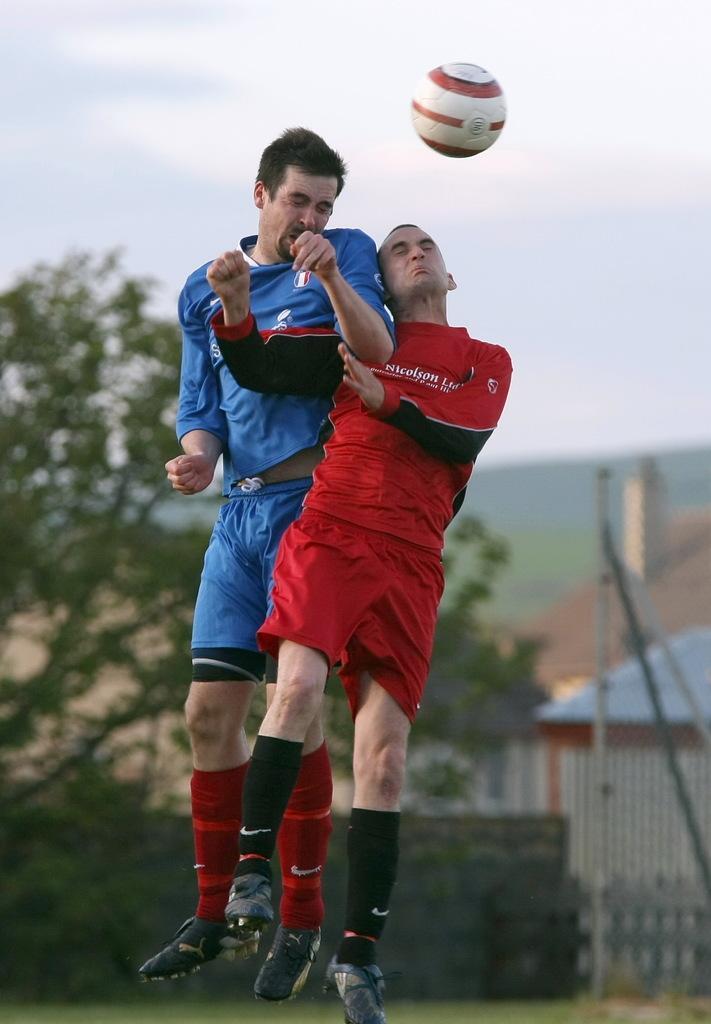Describe this image in one or two sentences. In the center of the image we can see men jumping. In the background we can see trees, buildings, hill and sky. 